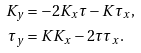Convert formula to latex. <formula><loc_0><loc_0><loc_500><loc_500>K _ { y } & = - 2 K _ { x } \tau - K \tau _ { x } , \\ \tau _ { y } & = K K _ { x } - 2 \tau \tau _ { x } .</formula> 